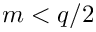<formula> <loc_0><loc_0><loc_500><loc_500>m < q / 2</formula> 